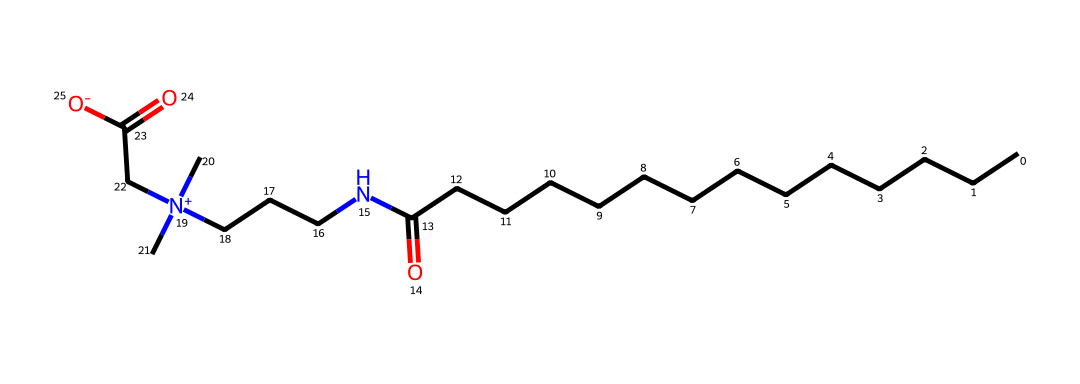What is the main functional group present in cocamidopropyl betaine? The chemical structure has an amine (N) and a carboxylic acid (C=O with -OH), indicating the presence of amide and carboxyl functional groups.
Answer: amide and carboxyl How many carbon atoms are in cocamidopropyl betaine? By analyzing the SMILES, we can count the series of 'C' characters that denote carbon atoms. The structure shows 17 carbon atoms in total.
Answer: 17 What type of surfactant is cocamidopropyl betaine classified as? Based on its structure, which shows a quaternary ammonium ion, it is categorized as a zwitterionic surfactant due to the presence of both positive and negative charges in the molecule.
Answer: zwitterionic What are the primary uses of cocamidopropyl betaine in hair care products? Cocamidopropyl betaine is commonly used as a foam booster and conditioning agent due to its surfactant properties that enhance the feel and lather in hair products.
Answer: foam booster and conditioning agent How many nitrogen atoms are present in the structure of cocamidopropyl betaine? The SMILES representation contains two nitrogen atoms, one in the amide bond and one in the quaternary ammonium group.
Answer: 2 Which part of the molecule contributes to its surfactant properties? The quaternary ammonium nitrogen's positive charge interacts with water, while the hydrophobic carbon chain assists in reducing surface tension, making these elements critical for surfactant action.
Answer: quaternary ammonium nitrogen and hydrophobic carbon chain 